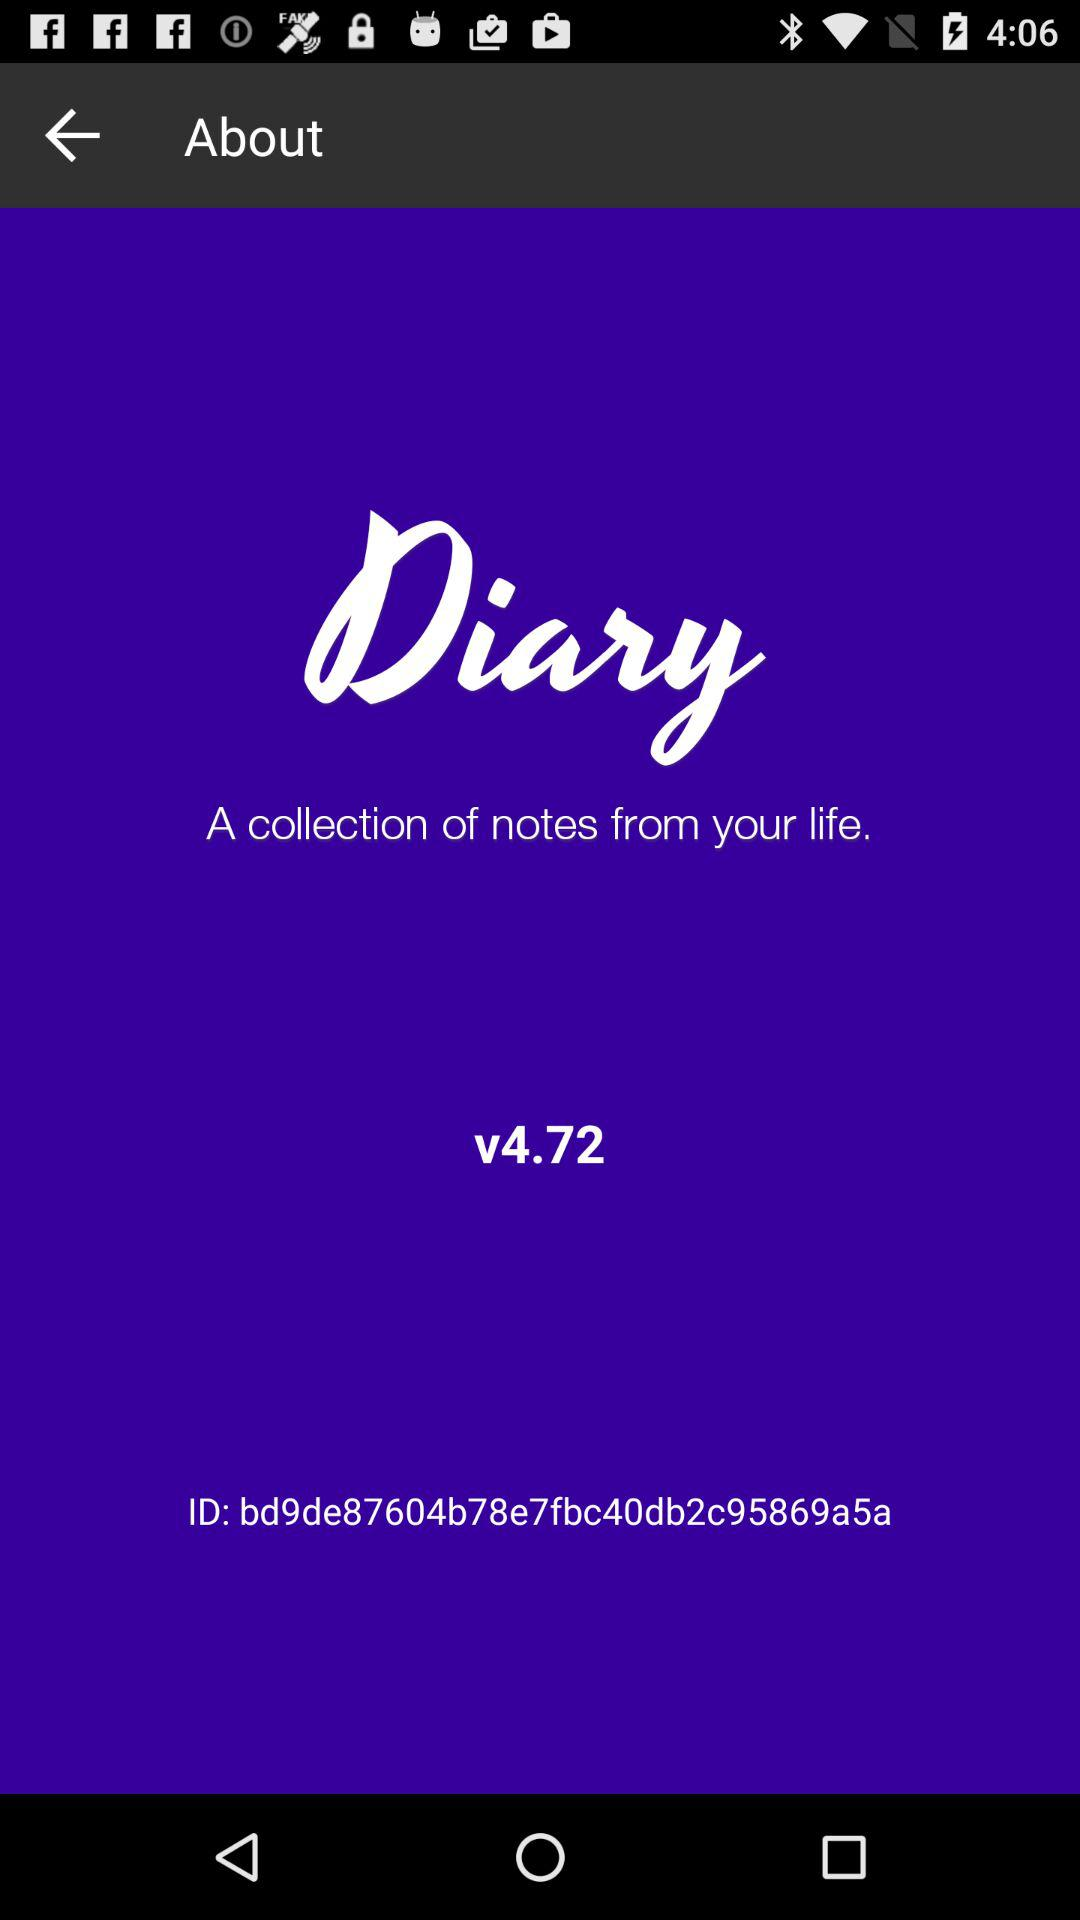What other information is visible in the image about the application? Aside from the application name 'Diary', the image indicates that it is currently at version 4.72. There is also a unique ID mentioned at the bottom, 'ID: bd9de87604b78e7fbc40db2c95869a5a', which could potentially be used for support or technical issues. 